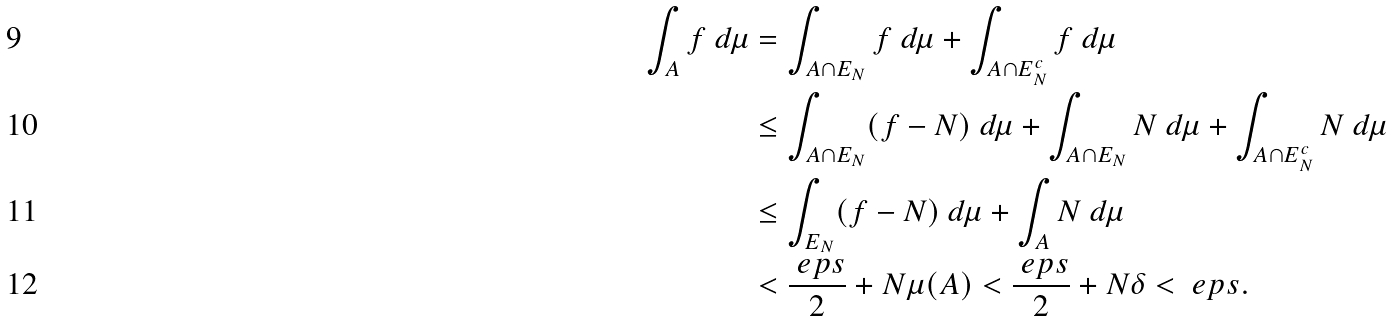Convert formula to latex. <formula><loc_0><loc_0><loc_500><loc_500>\int _ { A } f \ d \mu & = \int _ { A \cap E _ { N } } f \ d \mu + \int _ { A \cap E _ { N } ^ { c } } f \ d \mu \\ & \leq \int _ { A \cap E _ { N } } ( f - N ) \ d \mu + \int _ { A \cap E _ { N } } N \ d \mu + \int _ { A \cap E _ { N } ^ { c } } N \ d \mu \\ & \leq \int _ { E _ { N } } ( f - N ) \ d \mu + \int _ { A } N \ d \mu \\ & < \frac { \ e p s } { 2 } + N \mu ( A ) < \frac { \ e p s } { 2 } + N \delta < \ e p s .</formula> 